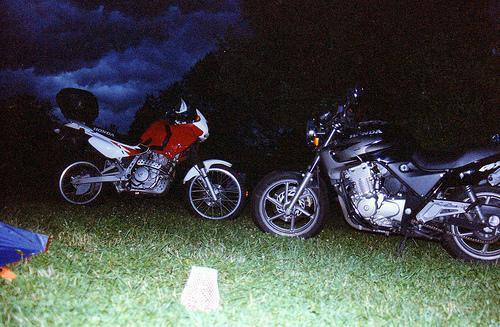How many motorcycles are in the photo?
Give a very brief answer. 2. 